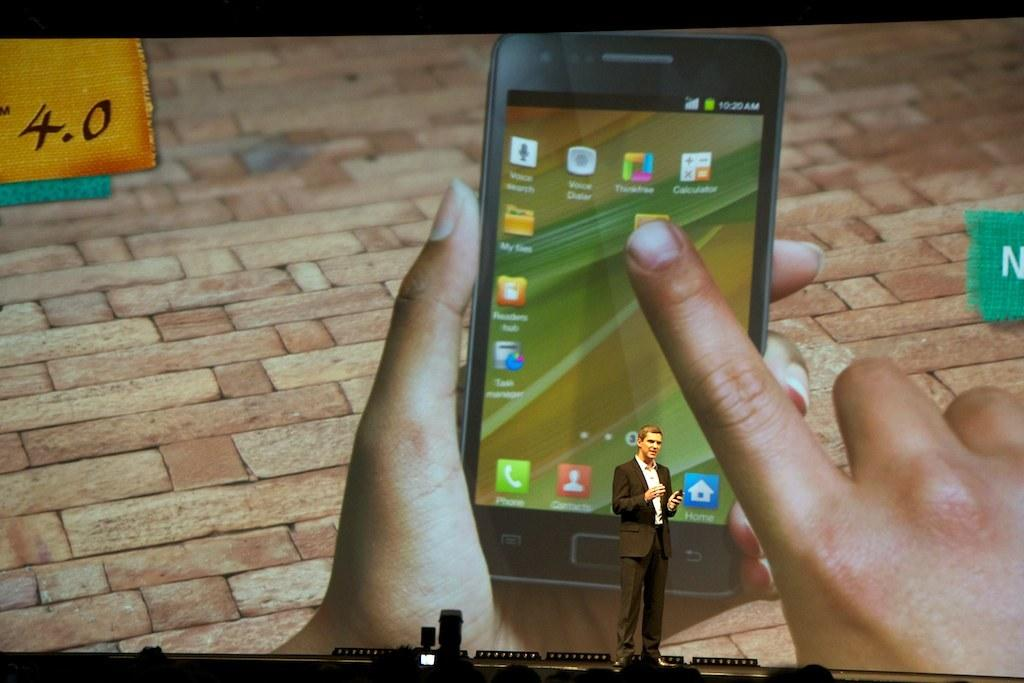<image>
Give a short and clear explanation of the subsequent image. 10:20 AM reads the digital display of this smart phone. 